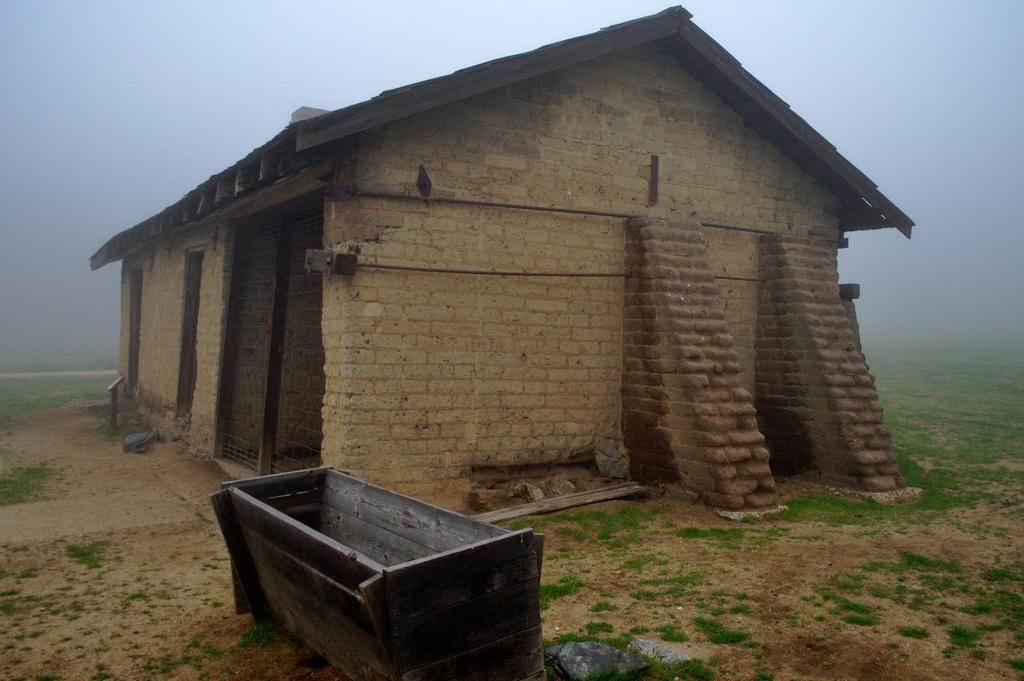Could you give a brief overview of what you see in this image? In this picture we can see a hut, made of brick walls and wooden rooftop surrounded by fog and grass. Here we can see a wooden tub. 